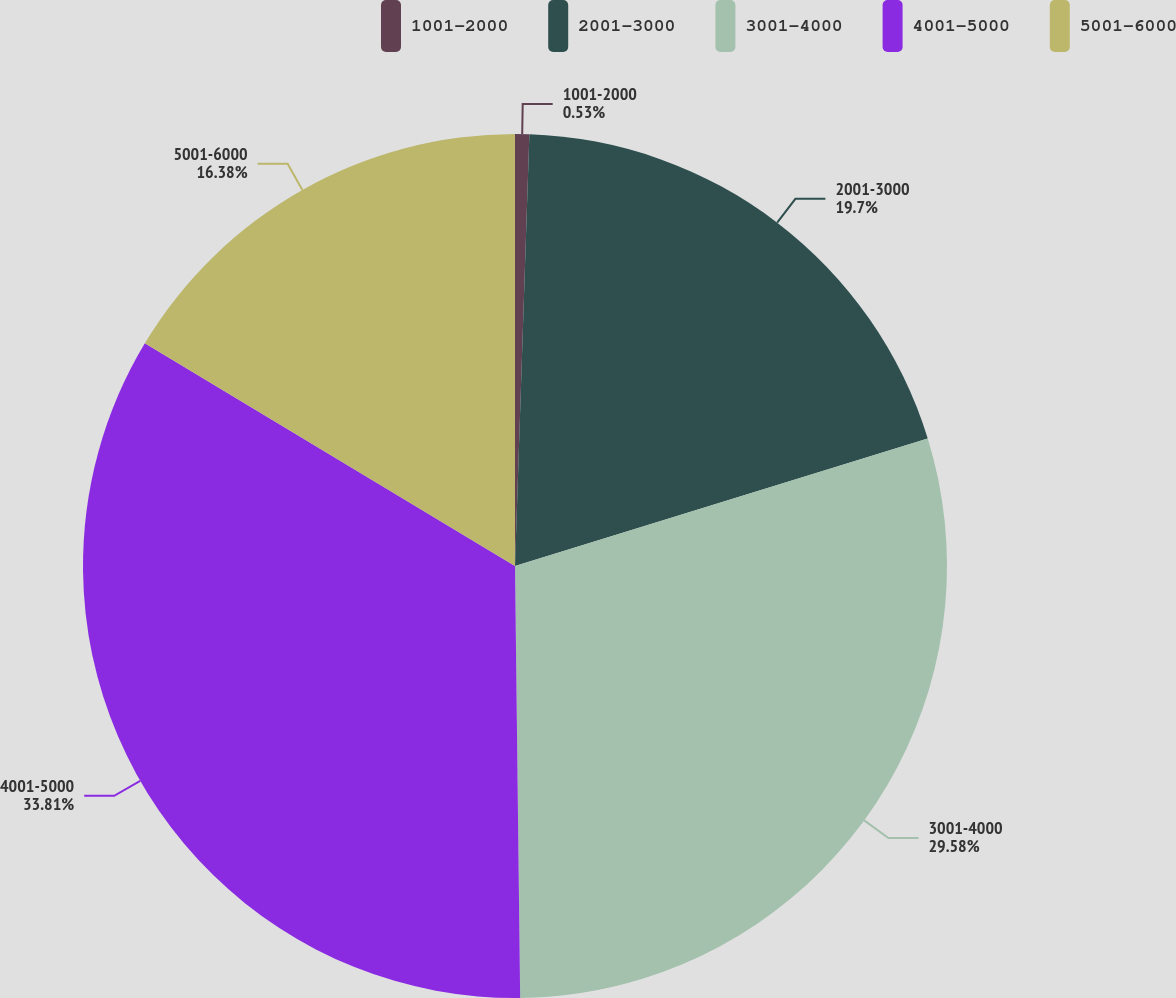Convert chart. <chart><loc_0><loc_0><loc_500><loc_500><pie_chart><fcel>1001-2000<fcel>2001-3000<fcel>3001-4000<fcel>4001-5000<fcel>5001-6000<nl><fcel>0.53%<fcel>19.7%<fcel>29.58%<fcel>33.81%<fcel>16.38%<nl></chart> 